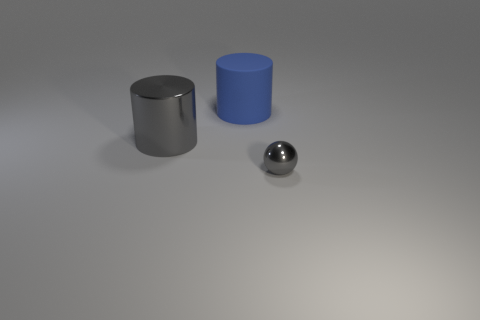What is the size of the object that is right of the big object behind the object to the left of the big matte thing?
Your answer should be very brief. Small. Are there any large brown metal spheres?
Keep it short and to the point. No. What is the material of the cylinder that is the same color as the tiny metal thing?
Make the answer very short. Metal. How many cylinders are the same color as the small object?
Offer a terse response. 1. How many objects are gray metallic objects to the left of the blue object or things that are on the right side of the gray shiny cylinder?
Give a very brief answer. 3. How many gray shiny things are in front of the metal object that is to the left of the gray metallic ball?
Provide a short and direct response. 1. What color is the large cylinder that is made of the same material as the ball?
Ensure brevity in your answer.  Gray. Are there any shiny objects that have the same size as the gray metallic sphere?
Offer a terse response. No. There is a blue rubber thing that is the same size as the gray metal cylinder; what shape is it?
Keep it short and to the point. Cylinder. Are there any other small shiny objects of the same shape as the tiny shiny object?
Make the answer very short. No. 